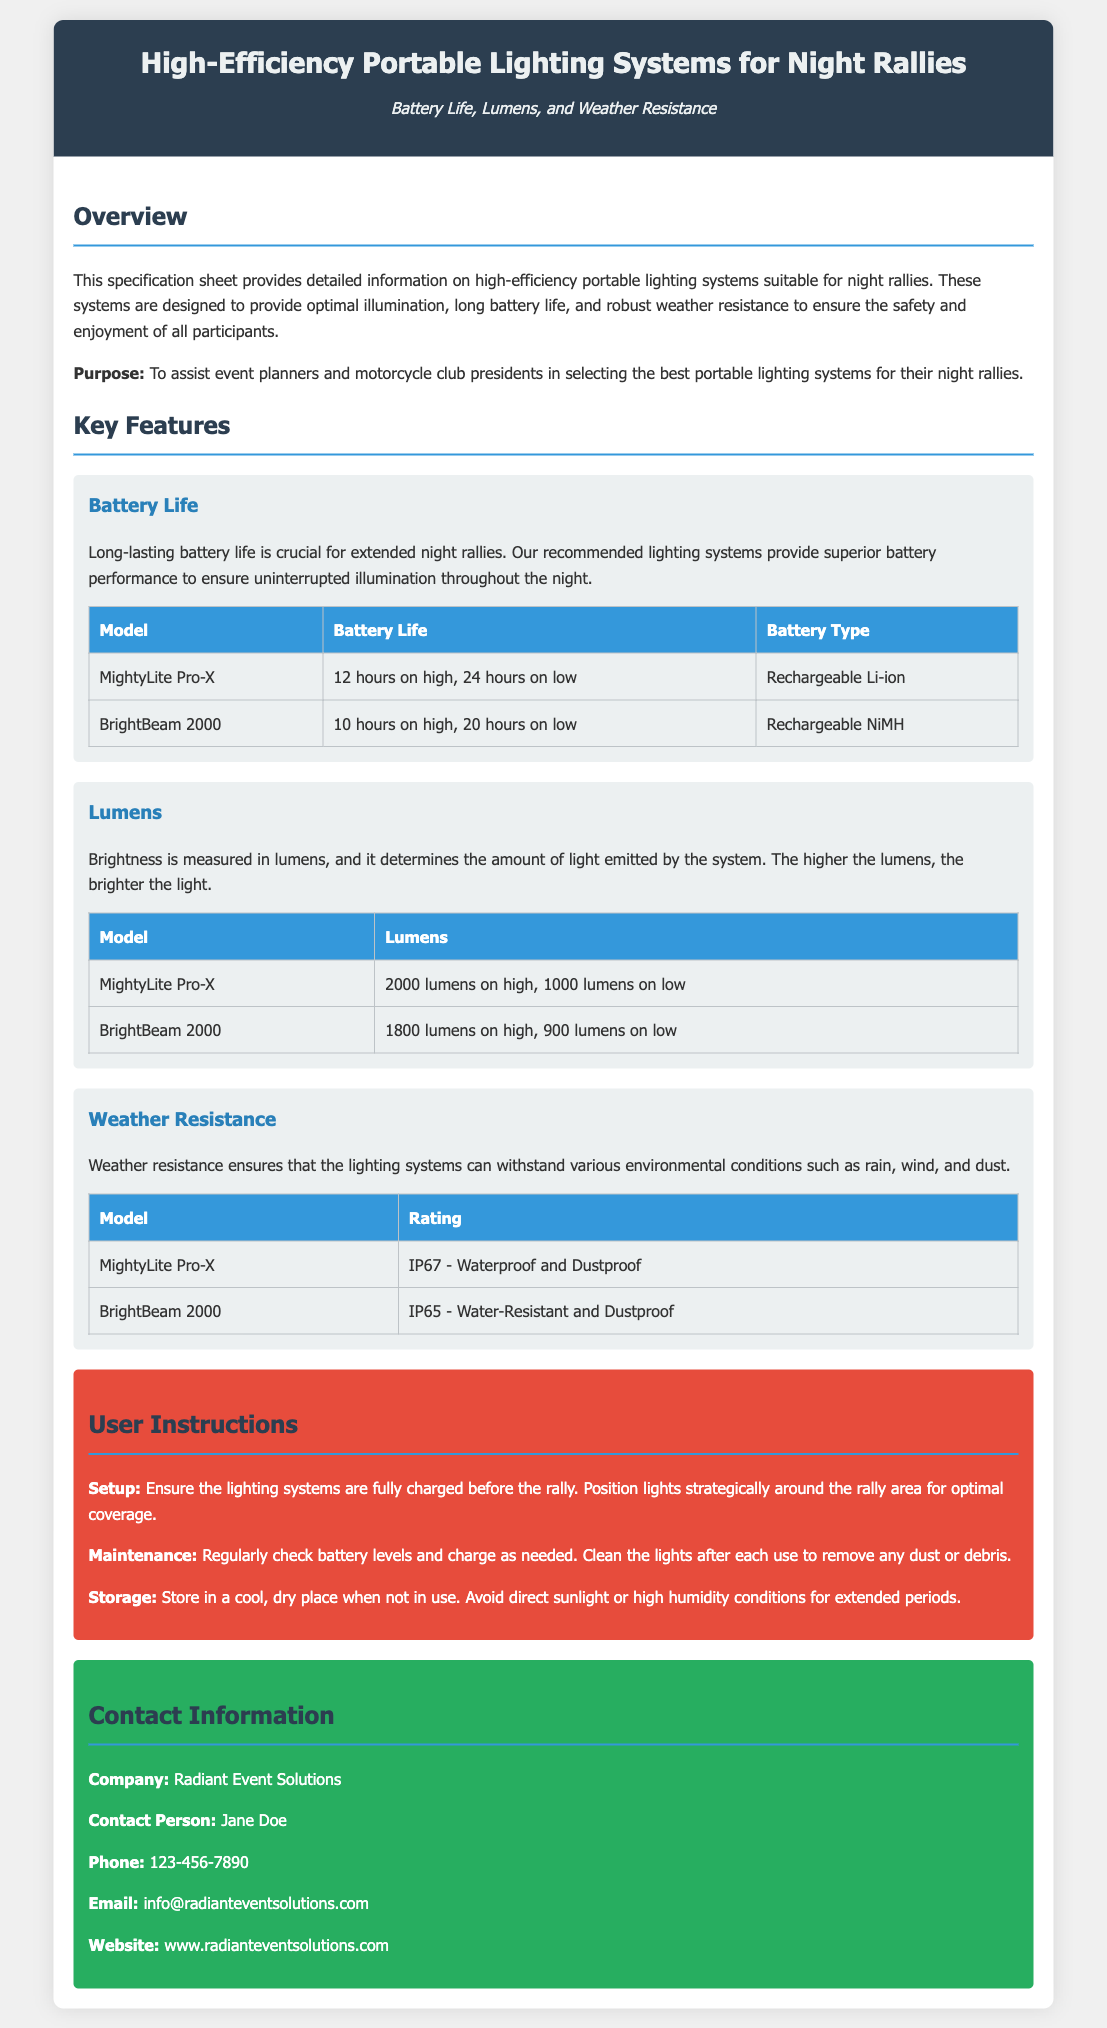What is the battery life of the MightyLite Pro-X on low? The battery life of the MightyLite Pro-X on low is mentioned in the table under the Battery Life section as 24 hours.
Answer: 24 hours What is the lumen output of the BrightBeam 2000 on high? The lumen output of the BrightBeam 2000 on high is specified in the Lumens table as 1800 lumens.
Answer: 1800 lumens What is the weather resistance rating of the MightyLite Pro-X? The weather resistance rating for the MightyLite Pro-X is provided in the Weather Resistance table as IP67.
Answer: IP67 Which battery type does the BrightBeam 2000 use? The battery type for the BrightBeam 2000 is listed in the Battery Life table as Rechargeable NiMH.
Answer: Rechargeable NiMH What is the main purpose of this specification sheet? The main purpose of the specification sheet is stated in the Overview section as to assist event planners and motorcycle club presidents in selecting the best portable lighting systems for their night rallies.
Answer: To assist event planners and motorcycle club presidents How long does the MightyLite Pro-X last on high? The runtime for MightyLite Pro-X on high is specified under Battery Life as 12 hours.
Answer: 12 hours What company provides these lighting systems? The company that provides the lighting systems is identified in the Contact Information section as Radiant Event Solutions.
Answer: Radiant Event Solutions What should be checked regularly according to the user instructions? The User Instructions recommend checking battery levels regularly.
Answer: Battery levels 